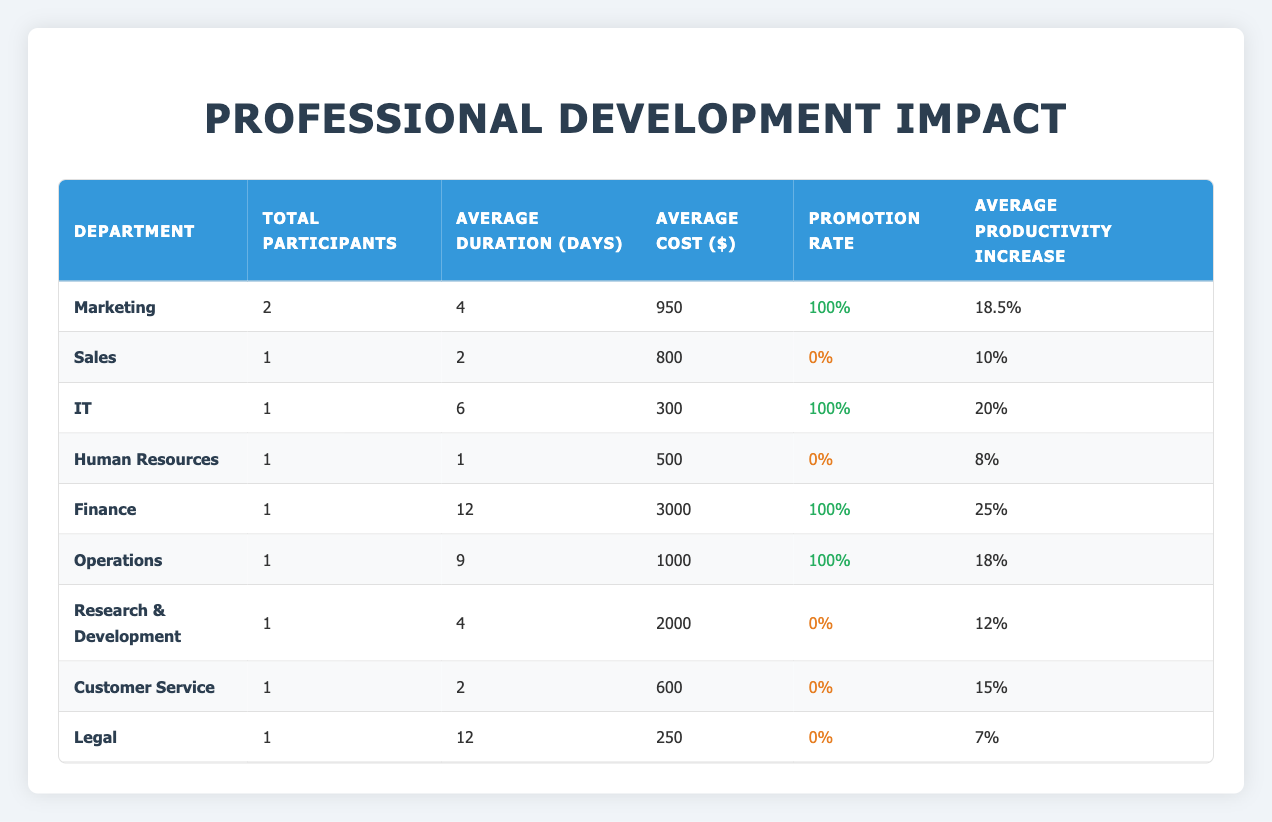What is the average cost of professional development activities in the Marketing department? There are 2 participants in the Marketing department with activity costs of 1500 and 400. To find the average cost, we sum the costs (1500 + 400 = 1900) and divide by the number of participants (1900 / 2 = 950).
Answer: 950 How many departments have a 100% promotion rate? There are four departments with a 100% promotion rate: Marketing, IT, Finance, and Operations. This is indicated in the table with a class "success" under the Promotion Rate column for these departments.
Answer: 4 What is the difference between the average productivity increase of the Finance department and the Sales department? The Finance department has an average productivity increase of 25%, while the Sales department has an average productivity increase of 10%. The difference is calculated as 25 - 10 = 15.
Answer: 15 Is there a correlation between cost and promotion rate? From the table, we observe that high costs do not consistently lead to promotions across departments. The Finance department has the highest cost but a promotion rate of 100%, while the Sales department has a lower cost and a 0% promotion rate. Therefore, we can conclude there is no strong correlation.
Answer: No Which department has the highest average productivity increase among those with a promotion within 1 year? The departments with a promotion within 1 year are Marketing, IT, Finance, and Operations, with productivity increases of 18.5%, 20%, 25%, and 18% respectively. The Finance department has the highest at 25%.
Answer: Finance What is the total number of participants across all departments? The total number of participants is obtained by summing the Total Participants column for all departments: 2 (Marketing) + 1 (Sales) + 1 (IT) + 1 (HR) + 1 (Finance) + 1 (Operations) + 1 (R&D) + 1 (Customer Service) + 1 (Legal) = 10.
Answer: 10 How does the average duration of professional development activities in the Human Resources department compare to the overall average duration? The Human Resources department has a duration of 1 day, while the overall total duration is calculated as follows: (4 + 2 + 6 + 1 + 12 + 9 + 4 + 2 + 12) / 9 = 6. The comparison shows that 1 is less than 6.
Answer: Less than What percentage of total participants received a promotion within a year? There are 10 total participants, and 6 (Marketing, IT, Finance, Operations, and 1 from another activity) received promotions. The percentage is calculated as (6/10) * 100 = 60%.
Answer: 60% 